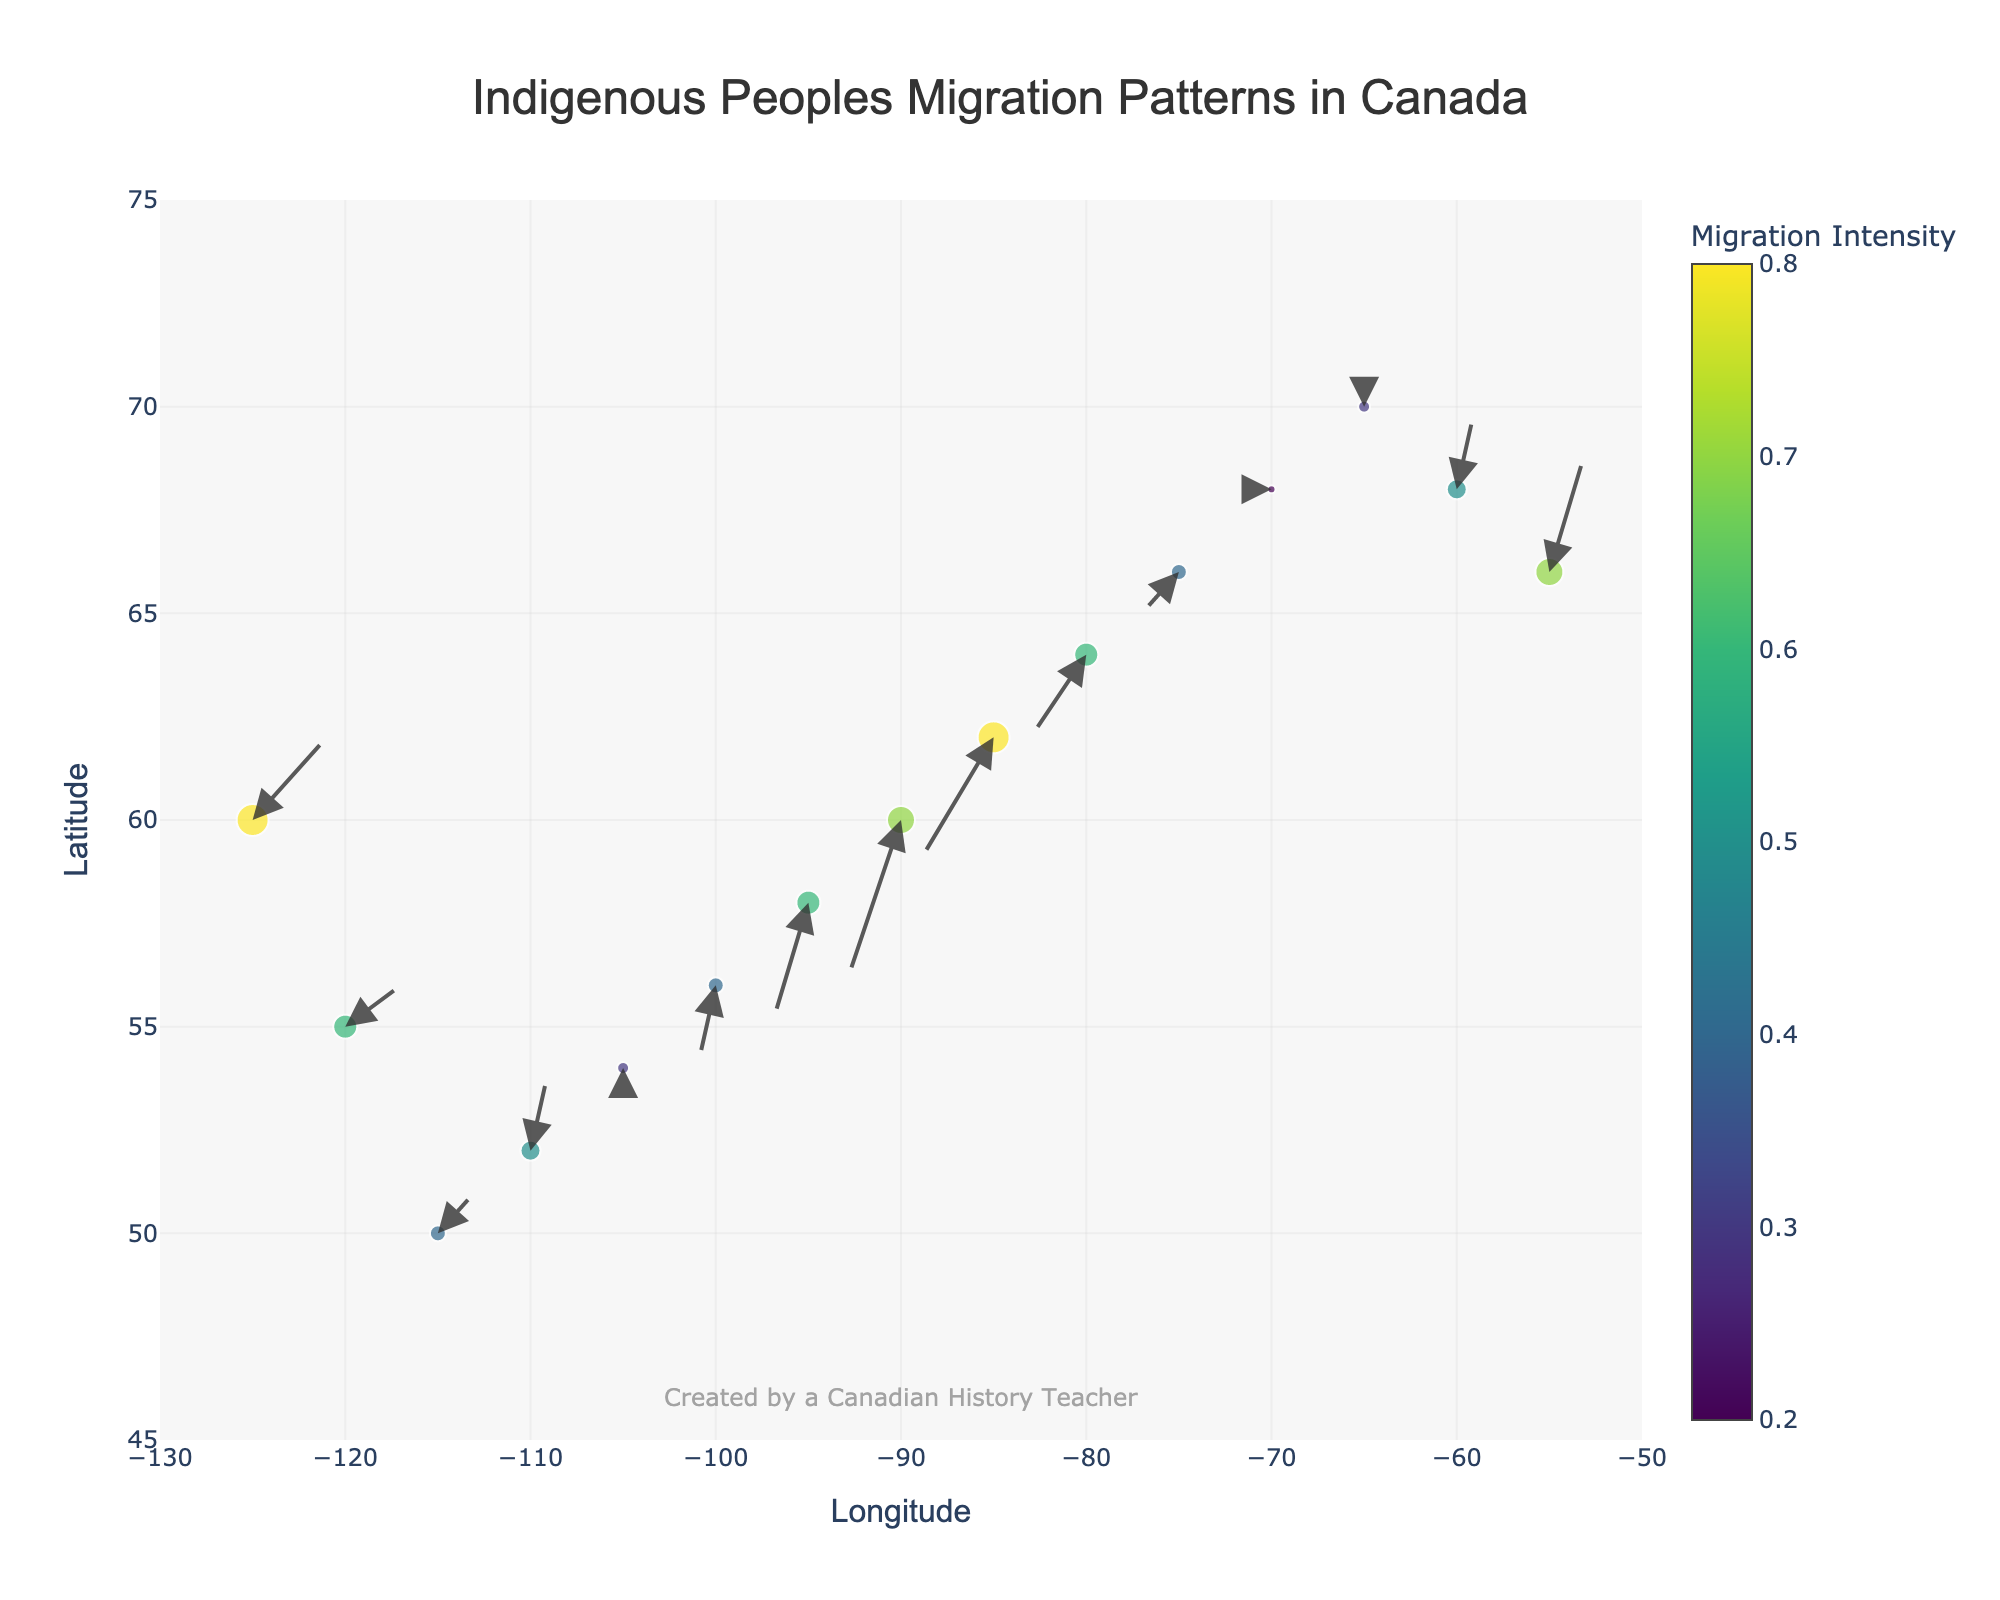What is the title of the figure? The title of the figure is prominently displayed at the top and reads "Indigenous Peoples Migration Patterns in Canada".
Answer: Indigenous Peoples Migration Patterns in Canada How many data points are represented in the plot? By counting all the points where the arrows originate from, we find there are 14 data points represented in the plot.
Answer: 14 Which data point has the highest migration intensity? Migration intensity is shown by the size and color of the markers. The data point at coordinates (-125, 60) and (-85, 62) both have the highest intensity, as their markers are the largest and darkest in color.
Answer: (-125, 60) and (-85, 62) What is the range of the y-axis (latitude)? The y-axis (latitude) range can be observed from the axis labels. It ranges from 45 to 75 degrees.
Answer: 45 to 75 degrees Comparing the data points at (-85, 62) and (-65, 70), which one has a stronger migration intensity? By looking at the sizes and colors of the markers, the data point at (-85, 62) has a larger and darker marker compared to (-65, 70), indicating a higher migration intensity.
Answer: (-85, 62) What direction does the migration arrow at (-100, 56) point to? The migration arrow at (-100, 56) points in the negative x and negative y direction, indicating movement towards the south-west.
Answer: South-West How does the size and color of markers represent migration intensity in the figure? Larger markers with darker colors signify higher migration intensity, whereas smaller markers with lighter colors signify lower migration intensity.
Answer: Larger and darker markers indicate higher intensity What general migration direction is illustrated by the arrows on the western side and eastern side of the map? On the western side (left), the arrows generally point eastward (indicating migration to the right). On the eastern side (right), the arrows generally point westward (indicating migration to the left).
Answer: Westward on the eastern side, eastward on the western side Which data point has an arrow pointing directly north? The data point at (-110, 52) has an arrow pointing directly north as it shows a movement with a positive vertical direction component and no horizontal direction component.
Answer: (-110, 52) What is the total movement in the y-direction for the data point at (-75, 66)? The y-direction movement at (-75, 66) is represented by the value of the vertical arrow component, which is -0.5.
Answer: -0.5 